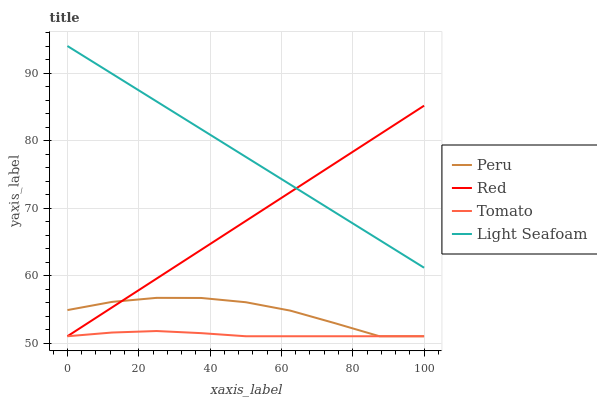Does Tomato have the minimum area under the curve?
Answer yes or no. Yes. Does Light Seafoam have the maximum area under the curve?
Answer yes or no. Yes. Does Red have the minimum area under the curve?
Answer yes or no. No. Does Red have the maximum area under the curve?
Answer yes or no. No. Is Light Seafoam the smoothest?
Answer yes or no. Yes. Is Peru the roughest?
Answer yes or no. Yes. Is Red the smoothest?
Answer yes or no. No. Is Red the roughest?
Answer yes or no. No. Does Tomato have the lowest value?
Answer yes or no. Yes. Does Light Seafoam have the lowest value?
Answer yes or no. No. Does Light Seafoam have the highest value?
Answer yes or no. Yes. Does Red have the highest value?
Answer yes or no. No. Is Tomato less than Light Seafoam?
Answer yes or no. Yes. Is Light Seafoam greater than Tomato?
Answer yes or no. Yes. Does Peru intersect Tomato?
Answer yes or no. Yes. Is Peru less than Tomato?
Answer yes or no. No. Is Peru greater than Tomato?
Answer yes or no. No. Does Tomato intersect Light Seafoam?
Answer yes or no. No. 